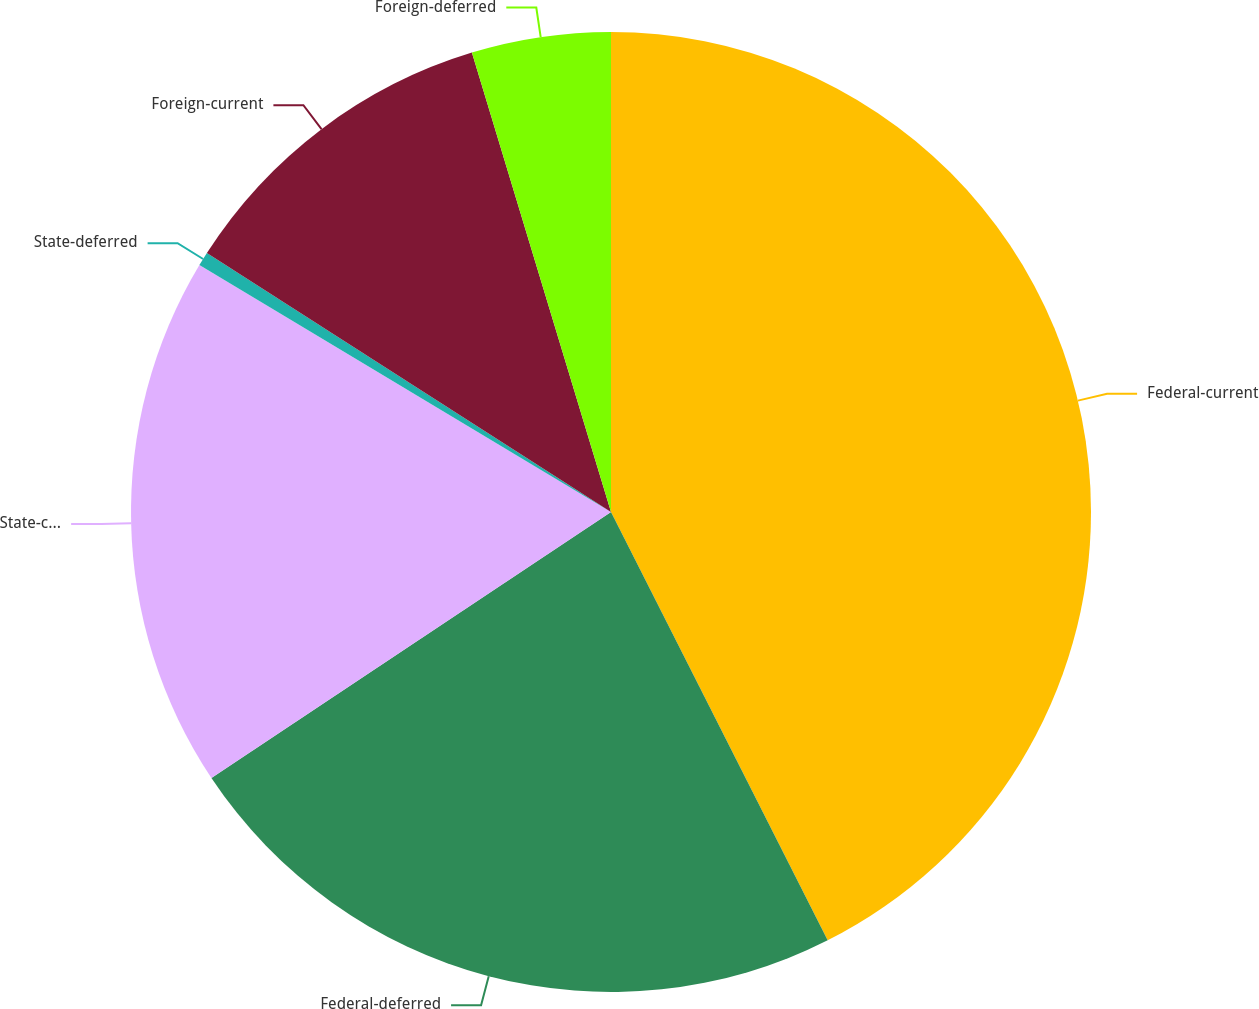<chart> <loc_0><loc_0><loc_500><loc_500><pie_chart><fcel>Federal-current<fcel>Federal-deferred<fcel>State-current<fcel>State-deferred<fcel>Foreign-current<fcel>Foreign-deferred<nl><fcel>42.55%<fcel>23.11%<fcel>17.95%<fcel>0.47%<fcel>11.25%<fcel>4.68%<nl></chart> 